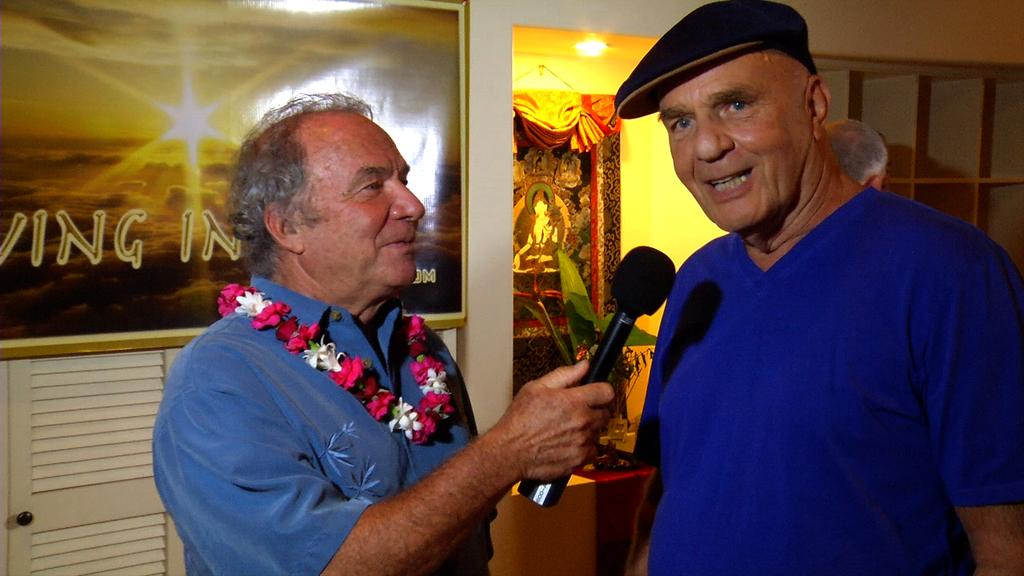How many people are in the image? There are two men in the image. What is one of the men doing? One of the men is holding a microphone. What is the other man doing? The other man is speaking. What can be seen on the wall in the background? There is a photo frame on the wall in the background. What type of pancake is being served on the table in the image? There is no table or pancake present in the image; it features two men, one holding a microphone and the other speaking, with a photo frame on the wall in the background. 